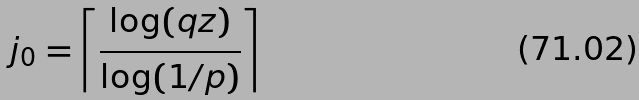<formula> <loc_0><loc_0><loc_500><loc_500>j _ { 0 } = \left \lceil \frac { \log ( q z ) } { \log ( 1 / p ) } \right \rceil</formula> 